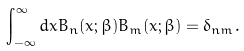Convert formula to latex. <formula><loc_0><loc_0><loc_500><loc_500>\int _ { - \infty } ^ { \infty } d x B _ { n } ( x ; \beta ) B _ { m } ( x ; \beta ) = \delta _ { n m } .</formula> 